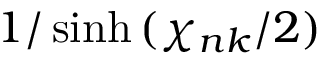<formula> <loc_0><loc_0><loc_500><loc_500>1 / \sinh { ( \chi _ { n k } / 2 ) }</formula> 